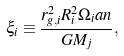Convert formula to latex. <formula><loc_0><loc_0><loc_500><loc_500>\xi _ { i } \equiv \frac { r _ { g , i } ^ { 2 } R _ { i } ^ { 2 } \Omega _ { i } a n } { G M _ { j } } ,</formula> 